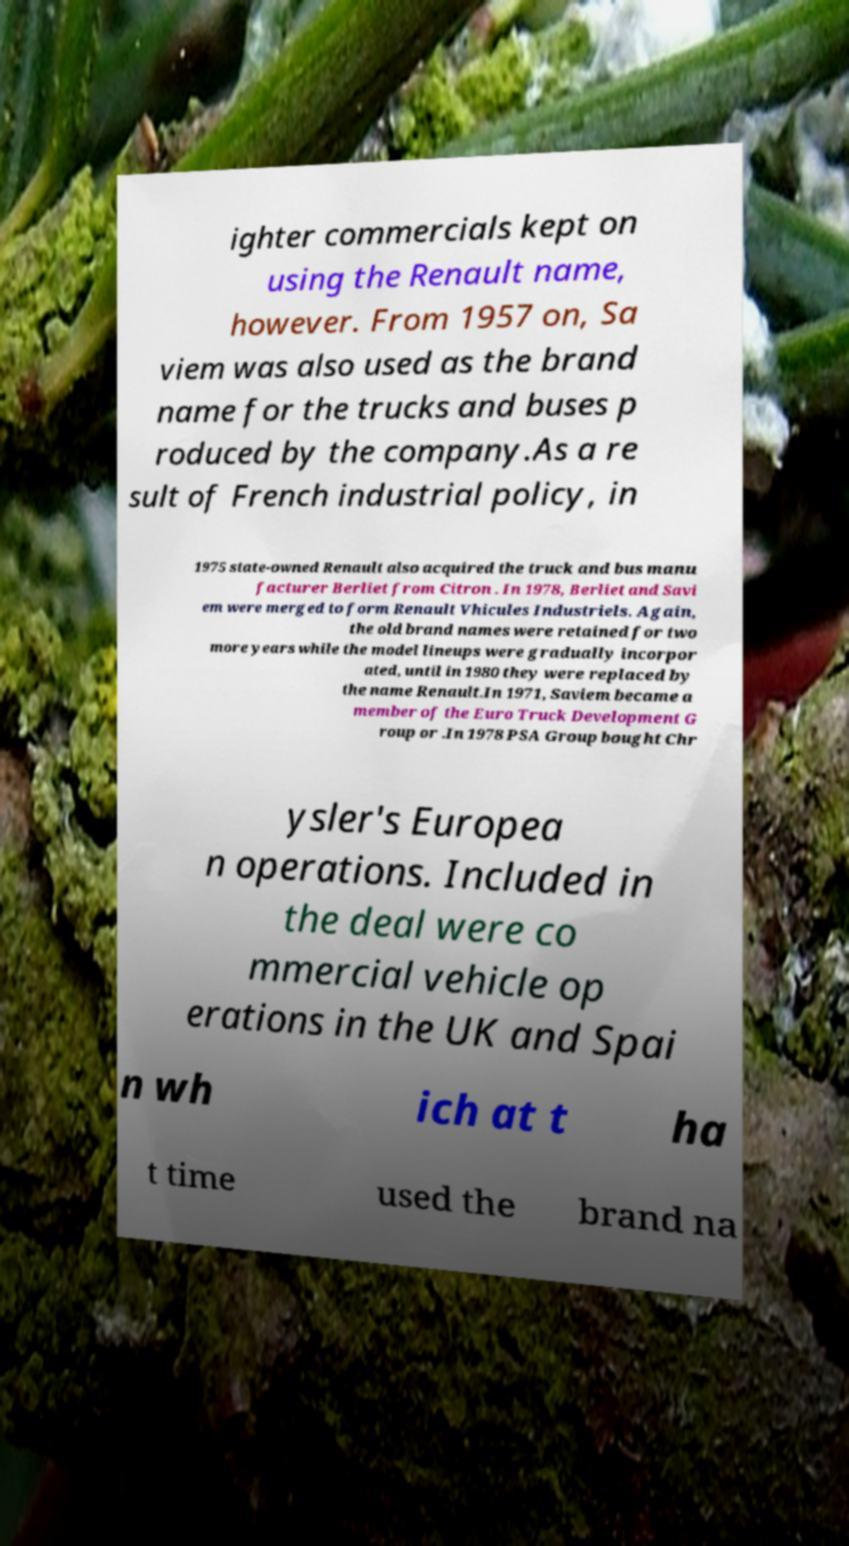Please identify and transcribe the text found in this image. ighter commercials kept on using the Renault name, however. From 1957 on, Sa viem was also used as the brand name for the trucks and buses p roduced by the company.As a re sult of French industrial policy, in 1975 state-owned Renault also acquired the truck and bus manu facturer Berliet from Citron . In 1978, Berliet and Savi em were merged to form Renault Vhicules Industriels. Again, the old brand names were retained for two more years while the model lineups were gradually incorpor ated, until in 1980 they were replaced by the name Renault.In 1971, Saviem became a member of the Euro Truck Development G roup or .In 1978 PSA Group bought Chr ysler's Europea n operations. Included in the deal were co mmercial vehicle op erations in the UK and Spai n wh ich at t ha t time used the brand na 